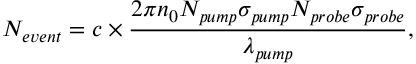<formula> <loc_0><loc_0><loc_500><loc_500>N _ { e v e n t } = c \times \frac { 2 \pi n _ { 0 } N _ { p u m p } \sigma _ { p u m p } N _ { p r o b e } \sigma _ { p r o b e } } { \lambda _ { p u m p } } ,</formula> 